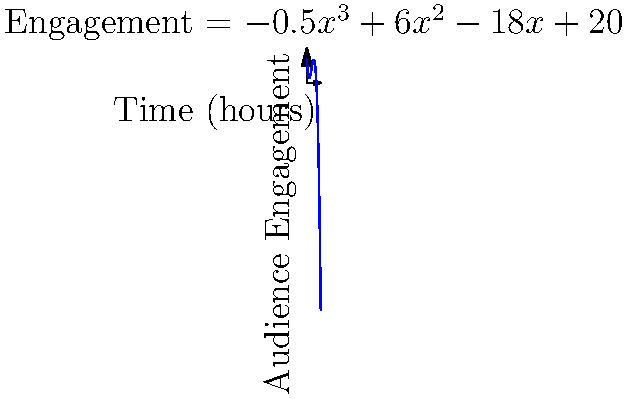Your social media team has modeled audience engagement over a 12-hour period using the polynomial function $E(t) = -0.5t^3 + 6t^2 - 18t + 20$, where $E$ represents engagement level and $t$ represents time in hours. At what time should you schedule your most important post to maximize audience engagement? To find the time of maximum engagement, we need to follow these steps:

1. Find the derivative of the engagement function:
   $E'(t) = -1.5t^2 + 12t - 18$

2. Set the derivative equal to zero to find critical points:
   $-1.5t^2 + 12t - 18 = 0$

3. Solve the quadratic equation:
   $-1.5(t^2 - 8t + 12) = 0$
   $-1.5(t - 6)(t - 2) = 0$
   $t = 6$ or $t = 2$

4. Check the second derivative to determine which critical point is the maximum:
   $E''(t) = -3t + 12$
   At $t = 2$: $E''(2) = 6$ (positive, local minimum)
   At $t = 6$: $E''(6) = -6$ (negative, local maximum)

5. Verify by evaluating $E(t)$ at both points:
   $E(2) = 24$
   $E(6) = 28$

Therefore, the maximum engagement occurs at $t = 6$ hours.
Answer: 6 hours 